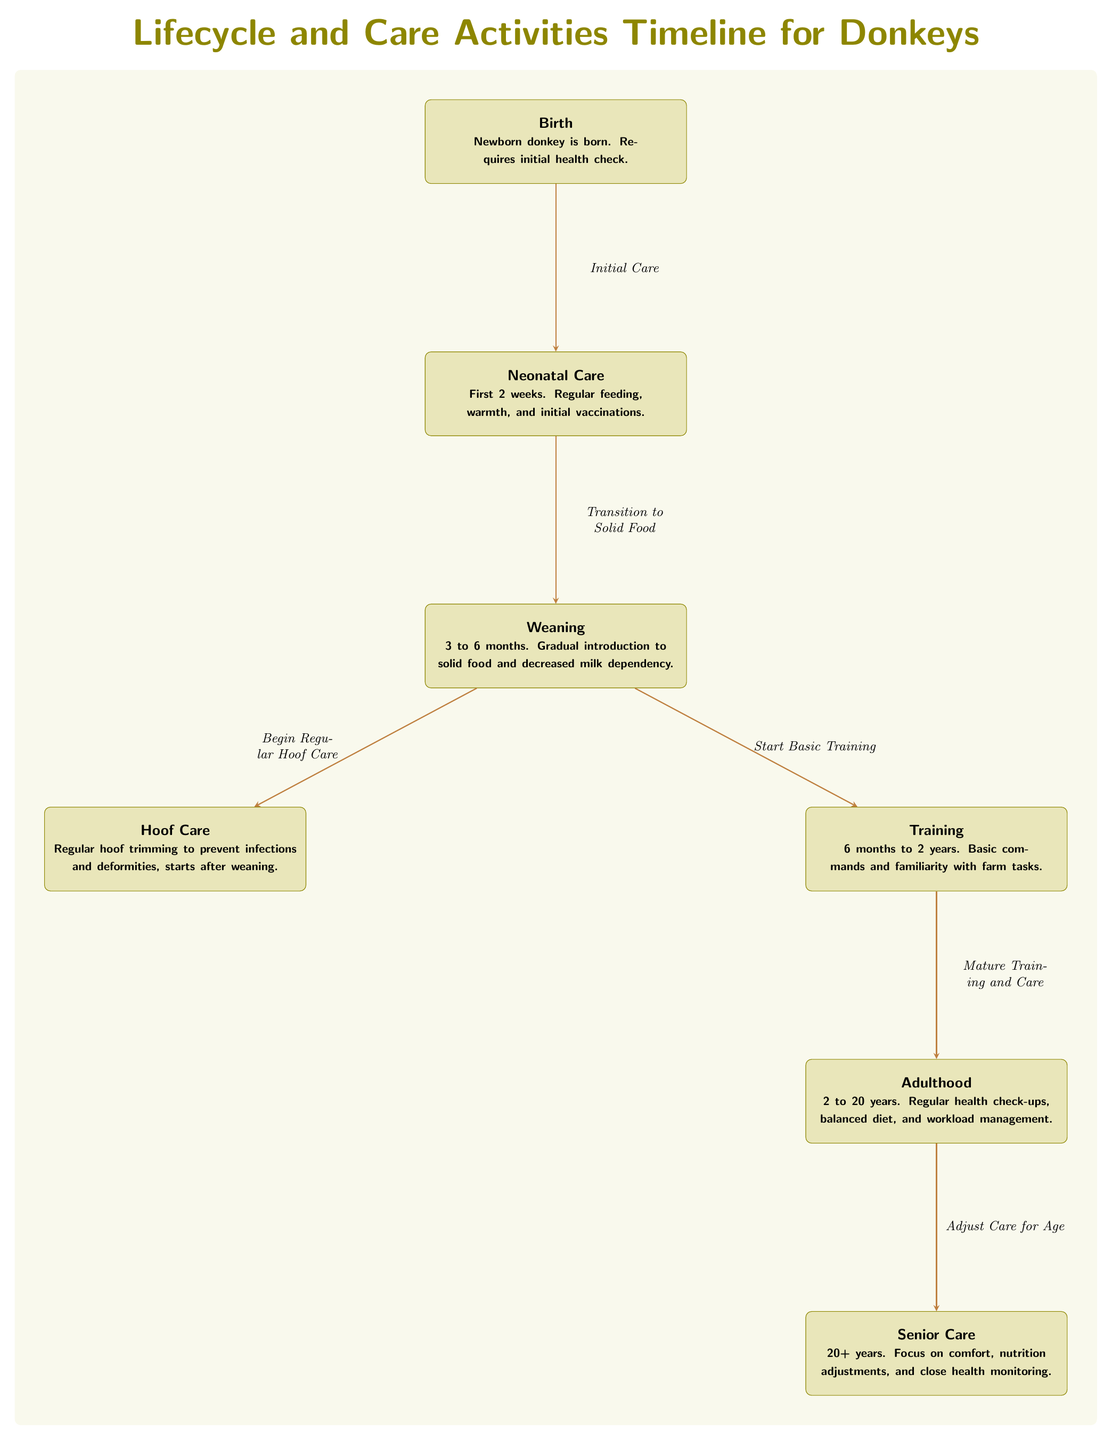What is the first stage in the donkey lifecycle? The diagram indicates "Birth" as the first node under the lifecycle timeline for donkeys, where a newborn donkey is born and requires an initial health check.
Answer: Birth How many main care stages are there in total? The diagram has seven nodes labeled Birth, Neonatal Care, Weaning, Hoof Care, Training, Adulthood, and Senior Care. Therefore, there are a total of seven main stages.
Answer: Seven What care activity begins after weaning? The diagram specifies that "Regular hoof trimming to prevent infections and deformities" begins after the weaning stage, indicating the start of hoof care.
Answer: Hoof Care At what age does training begin for donkeys? According to the diagram, training starts at six months of age and continues until two years, marking the beginning of familiarizing donkeys with basic commands and farm tasks.
Answer: Six months What significant transition occurs after neonatal care? The diagram shows an arrow leading from "Neonatal Care" to "Weaning," indicating that the transition to solid food takes place after the neonatal care stage.
Answer: Transition to Solid Food What adjustments are made during the senior care stage? The diagram highlights that during "Senior Care," the focus shifts to comfort and nutrition adjustments, along with close health monitoring, as donkeys age beyond 20 years.
Answer: Nutrition adjustments Which two care activities are initiated simultaneously after weaning? The diagram shows arrows leading from "Weaning" to both "Hoof Care" and "Training," indicating that both regular hoof care and basic training start simultaneously after weaning.
Answer: Hoof Care and Training What is the age range for the adulthood stage in donkeys? The diagram notes that the adulthood stage lasts from 2 years to 20 years, detailing the regular health check-ups and workload management needed during this time.
Answer: Two to twenty years What is the purpose of the maturity training and care? The diagram illustrates that "Mature Training and Care" refers to the continued care and further training of donkeys as they grow older, specifically during the adulthood stage.
Answer: Care and training 